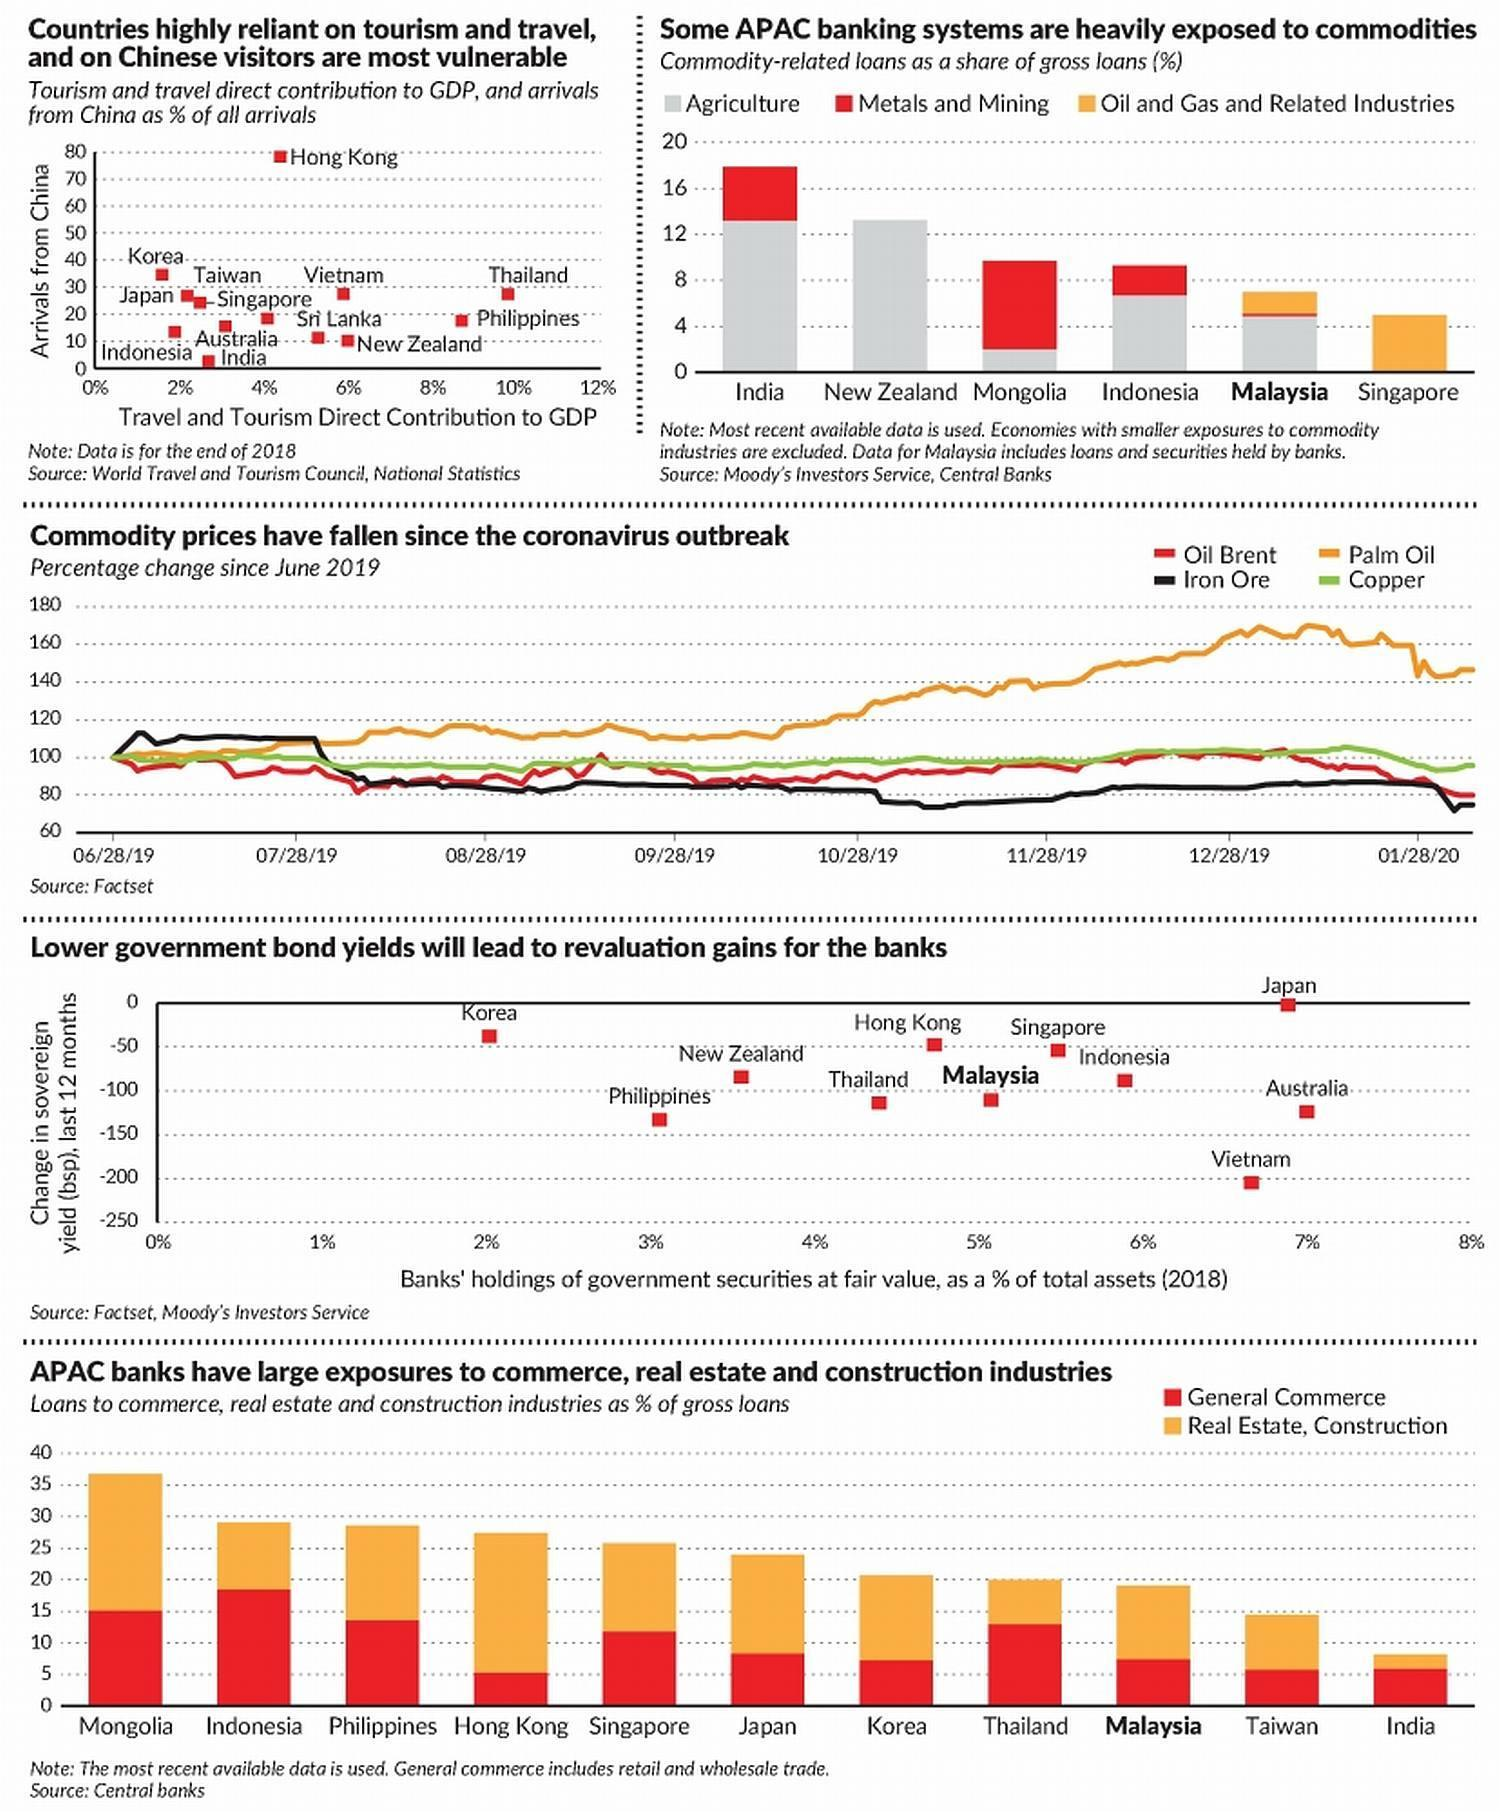Which countries travel and tourism contributes the highest to GDP?
Answer the question with a short phrase. Thailand How many graphs are in this infographic? 5 Which color is used to plot "Palm Oil"-red, copper, orange, or black? orange 